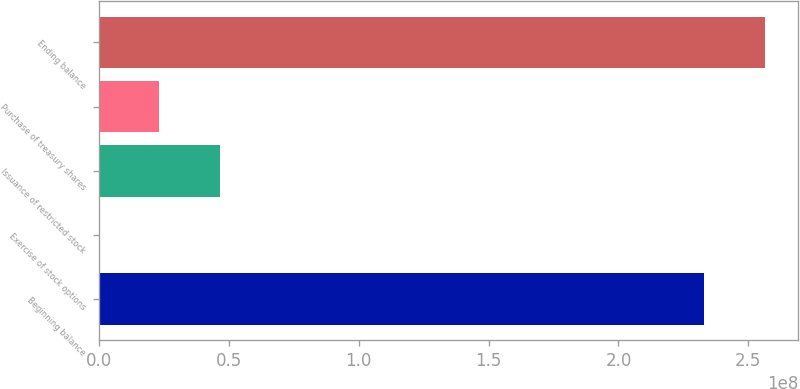Convert chart to OTSL. <chart><loc_0><loc_0><loc_500><loc_500><bar_chart><fcel>Beginning balance<fcel>Exercise of stock options<fcel>Issuance of restricted stock<fcel>Purchase of treasury shares<fcel>Ending balance<nl><fcel>2.33082e+08<fcel>17600<fcel>4.66369e+07<fcel>2.33273e+07<fcel>2.56391e+08<nl></chart> 